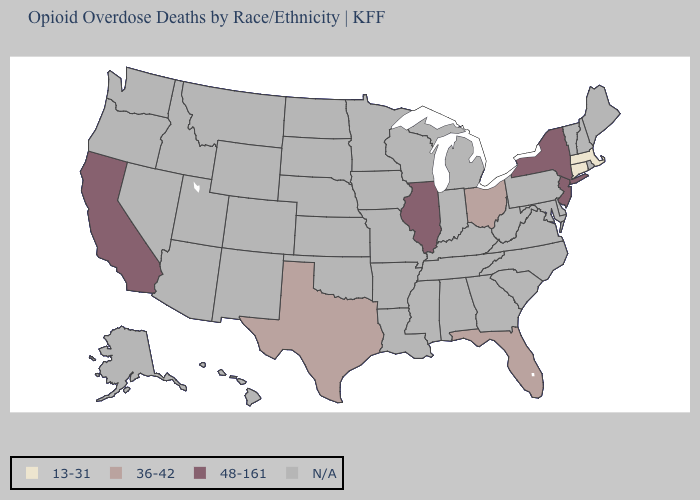Name the states that have a value in the range 48-161?
Write a very short answer. California, Illinois, New Jersey, New York. Does California have the highest value in the USA?
Quick response, please. Yes. How many symbols are there in the legend?
Give a very brief answer. 4. Name the states that have a value in the range 48-161?
Give a very brief answer. California, Illinois, New Jersey, New York. What is the value of Hawaii?
Give a very brief answer. N/A. Does Ohio have the lowest value in the MidWest?
Quick response, please. Yes. Does the map have missing data?
Quick response, please. Yes. What is the value of Idaho?
Concise answer only. N/A. What is the lowest value in the USA?
Write a very short answer. 13-31. What is the value of North Carolina?
Concise answer only. N/A. Among the states that border West Virginia , which have the lowest value?
Be succinct. Ohio. Name the states that have a value in the range 13-31?
Give a very brief answer. Connecticut, Massachusetts. Which states have the highest value in the USA?
Quick response, please. California, Illinois, New Jersey, New York. 